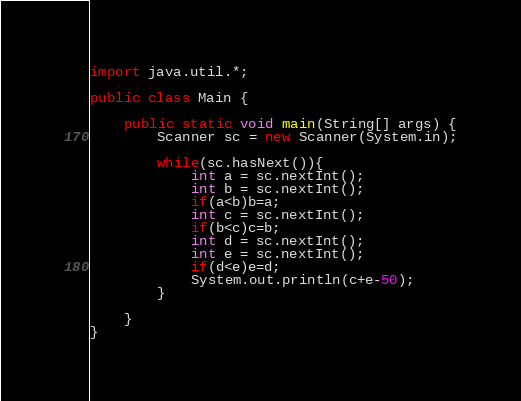<code> <loc_0><loc_0><loc_500><loc_500><_Java_>import java.util.*;

public class Main {
	
	public static void main(String[] args) {
		Scanner sc = new Scanner(System.in);
		
		while(sc.hasNext()){
			int a = sc.nextInt();
			int b = sc.nextInt();
			if(a<b)b=a;
			int c = sc.nextInt();
			if(b<c)c=b;
			int d = sc.nextInt();
			int e = sc.nextInt();
			if(d<e)e=d;
			System.out.println(c+e-50);
		}
		
	}	
}</code> 